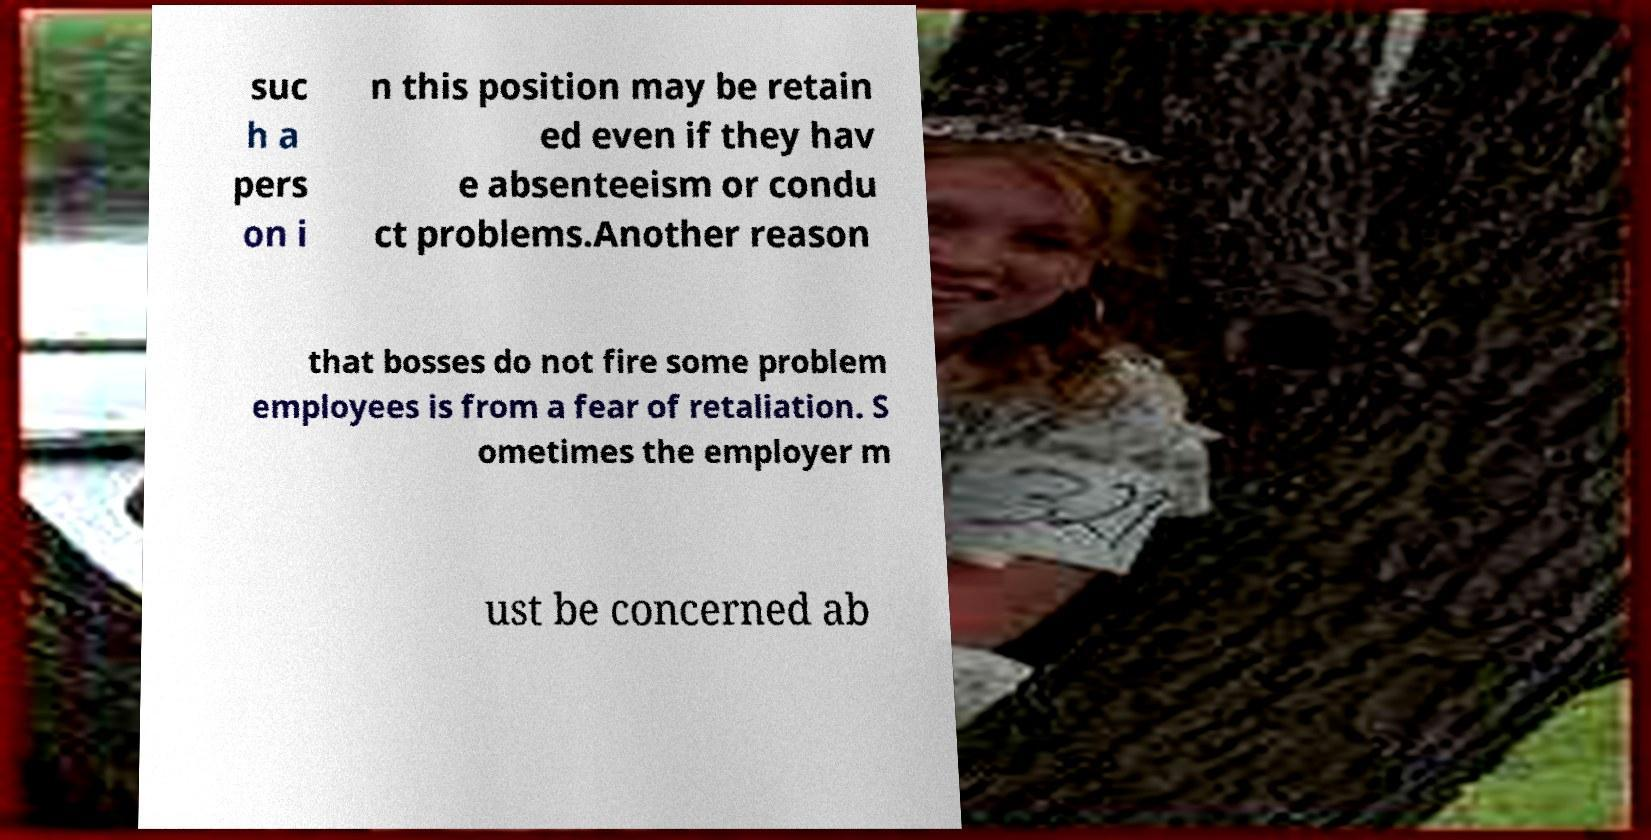For documentation purposes, I need the text within this image transcribed. Could you provide that? suc h a pers on i n this position may be retain ed even if they hav e absenteeism or condu ct problems.Another reason that bosses do not fire some problem employees is from a fear of retaliation. S ometimes the employer m ust be concerned ab 